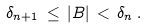Convert formula to latex. <formula><loc_0><loc_0><loc_500><loc_500>\delta _ { n + 1 } \, \leq \, | B | \, < \, \delta _ { n } \, .</formula> 